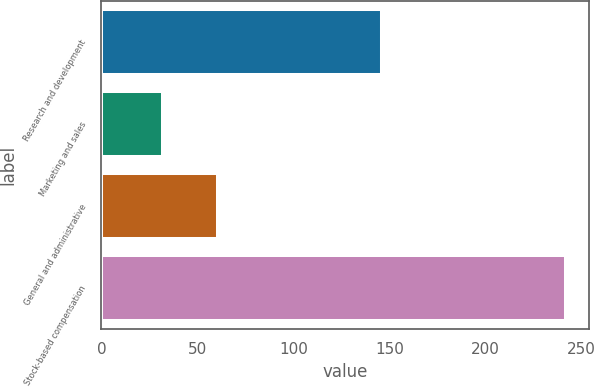<chart> <loc_0><loc_0><loc_500><loc_500><bar_chart><fcel>Research and development<fcel>Marketing and sales<fcel>General and administrative<fcel>Stock-based compensation<nl><fcel>146<fcel>32<fcel>61<fcel>242<nl></chart> 